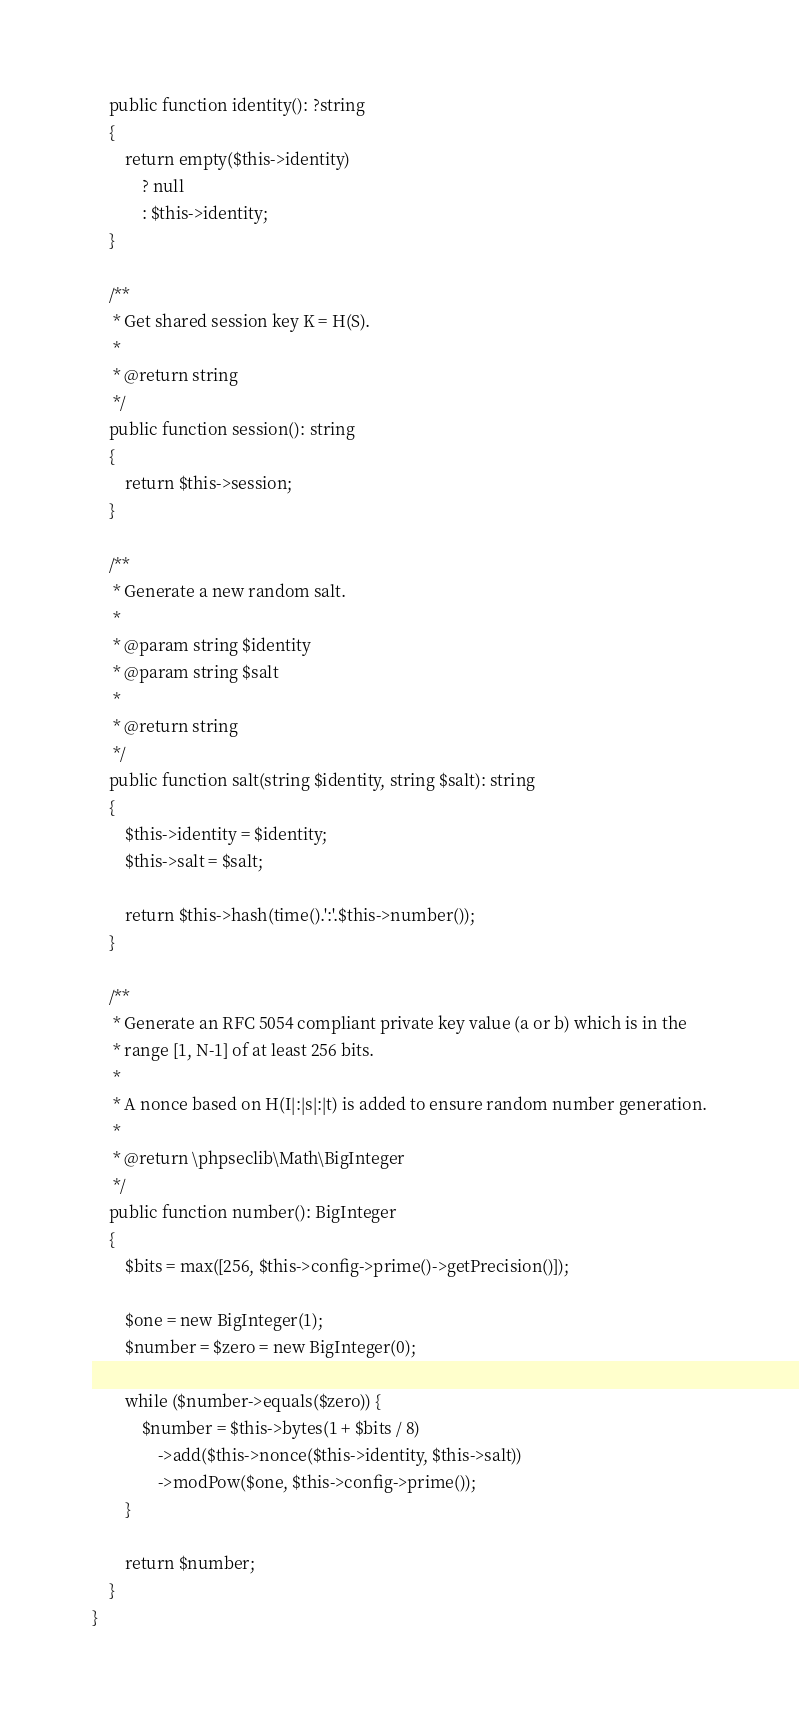<code> <loc_0><loc_0><loc_500><loc_500><_PHP_>    public function identity(): ?string
    {
        return empty($this->identity)
            ? null
            : $this->identity;
    }

    /**
     * Get shared session key K = H(S).
     *
     * @return string
     */
    public function session(): string
    {
        return $this->session;
    }

    /**
     * Generate a new random salt.
     *
     * @param string $identity
     * @param string $salt
     *
     * @return string
     */
    public function salt(string $identity, string $salt): string
    {
        $this->identity = $identity;
        $this->salt = $salt;

        return $this->hash(time().':'.$this->number());
    }

    /**
     * Generate an RFC 5054 compliant private key value (a or b) which is in the
     * range [1, N-1] of at least 256 bits.
     *
     * A nonce based on H(I|:|s|:|t) is added to ensure random number generation.
     *
     * @return \phpseclib\Math\BigInteger
     */
    public function number(): BigInteger
    {
        $bits = max([256, $this->config->prime()->getPrecision()]);

        $one = new BigInteger(1);
        $number = $zero = new BigInteger(0);

        while ($number->equals($zero)) {
            $number = $this->bytes(1 + $bits / 8)
                ->add($this->nonce($this->identity, $this->salt))
                ->modPow($one, $this->config->prime());
        }

        return $number;
    }
}
</code> 